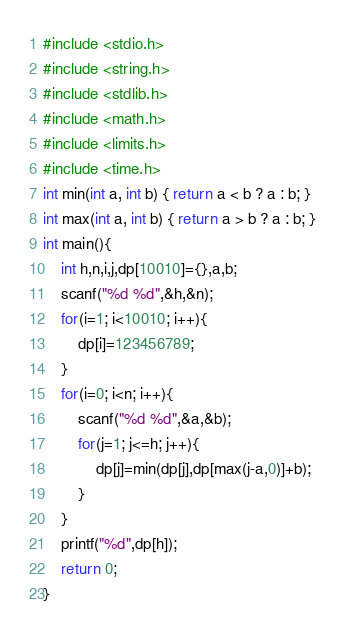Convert code to text. <code><loc_0><loc_0><loc_500><loc_500><_C_>#include <stdio.h>
#include <string.h>
#include <stdlib.h>
#include <math.h>
#include <limits.h>
#include <time.h>
int min(int a, int b) { return a < b ? a : b; }
int max(int a, int b) { return a > b ? a : b; }
int main(){
    int h,n,i,j,dp[10010]={},a,b;
    scanf("%d %d",&h,&n);
    for(i=1; i<10010; i++){
        dp[i]=123456789;
    }
    for(i=0; i<n; i++){
        scanf("%d %d",&a,&b);
        for(j=1; j<=h; j++){
            dp[j]=min(dp[j],dp[max(j-a,0)]+b);
        }
    }
    printf("%d",dp[h]);
    return 0;
}</code> 